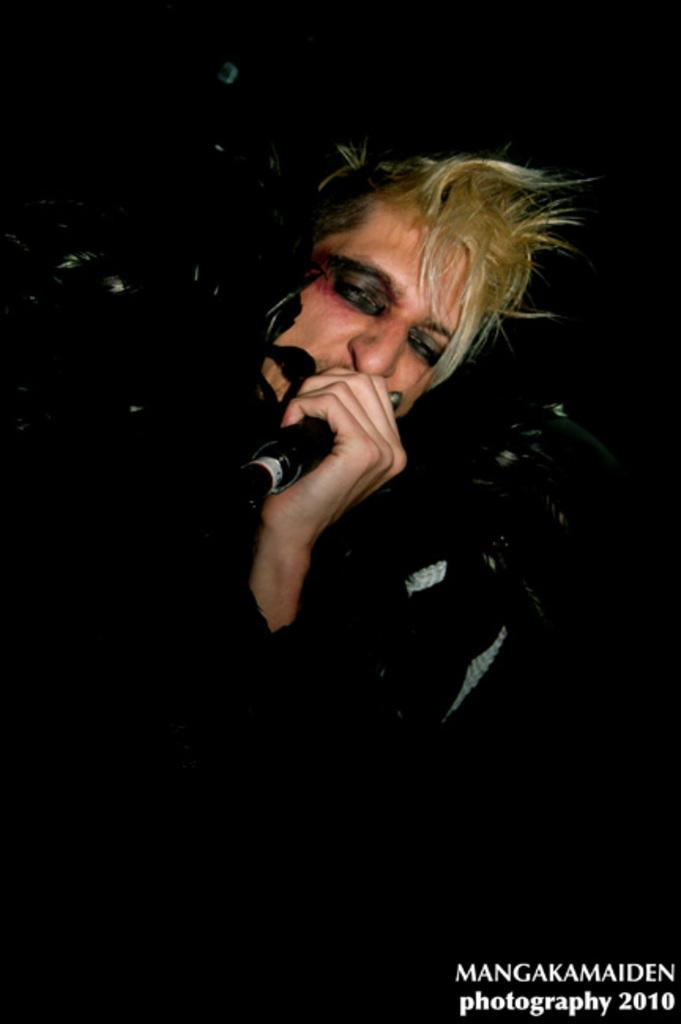What is the main subject of the image? There is a person in the image. Where is the person located in the image? The person is standing in the middle of the image. What is the person holding in the image? The person is holding a microphone. What type of kite is the person flying in the image? There is no kite present in the image; the person is holding a microphone. What is the person's emotional state in the image? The image does not provide information about the person's emotional state. 